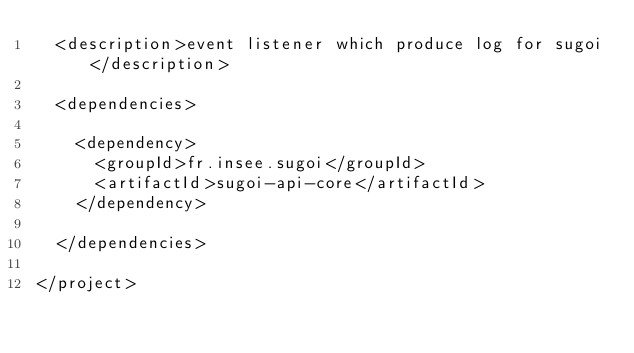<code> <loc_0><loc_0><loc_500><loc_500><_XML_>	<description>event listener which produce log for sugoi</description>

	<dependencies>

		<dependency>
			<groupId>fr.insee.sugoi</groupId>
			<artifactId>sugoi-api-core</artifactId>
		</dependency>

	</dependencies>

</project>
</code> 